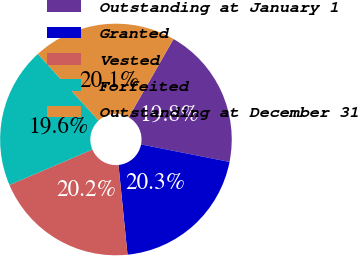Convert chart to OTSL. <chart><loc_0><loc_0><loc_500><loc_500><pie_chart><fcel>Outstanding at January 1<fcel>Granted<fcel>Vested<fcel>Forfeited<fcel>Outstanding at December 31<nl><fcel>19.82%<fcel>20.3%<fcel>20.17%<fcel>19.65%<fcel>20.06%<nl></chart> 